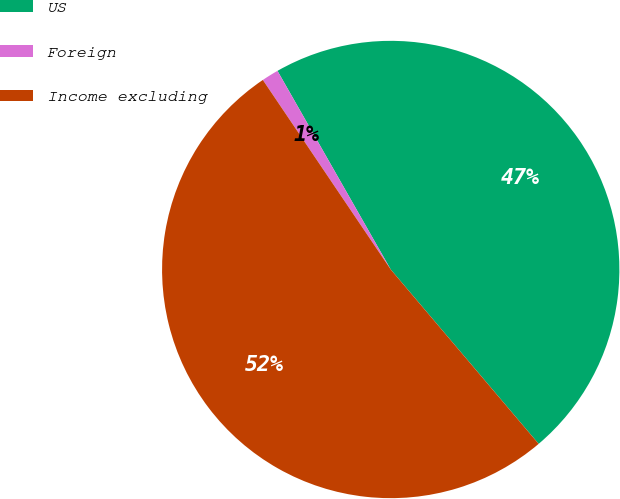<chart> <loc_0><loc_0><loc_500><loc_500><pie_chart><fcel>US<fcel>Foreign<fcel>Income excluding<nl><fcel>47.05%<fcel>1.2%<fcel>51.75%<nl></chart> 